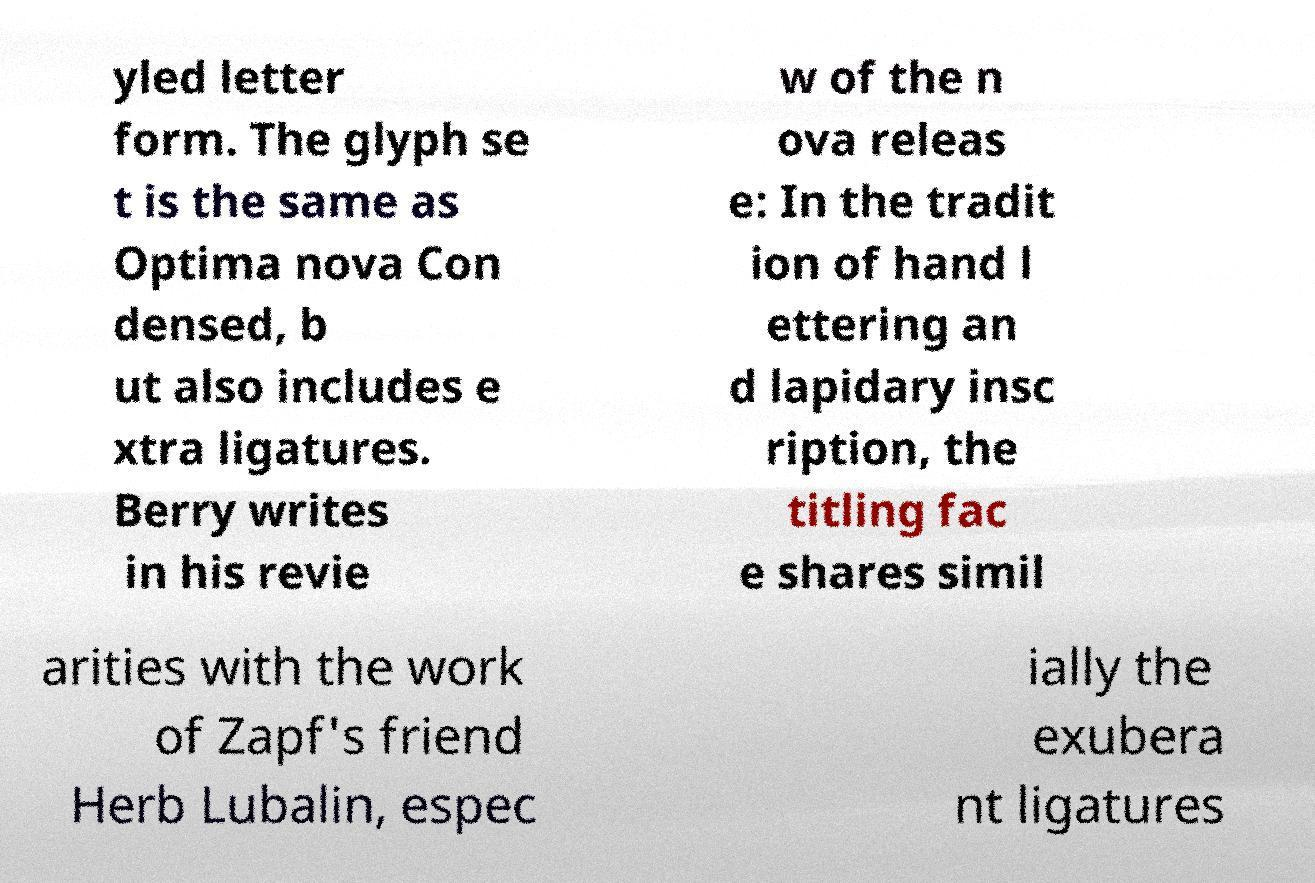Please read and relay the text visible in this image. What does it say? yled letter form. The glyph se t is the same as Optima nova Con densed, b ut also includes e xtra ligatures. Berry writes in his revie w of the n ova releas e: In the tradit ion of hand l ettering an d lapidary insc ription, the titling fac e shares simil arities with the work of Zapf's friend Herb Lubalin, espec ially the exubera nt ligatures 